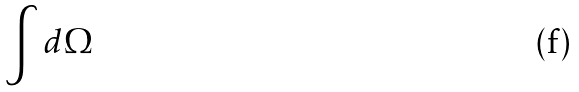Convert formula to latex. <formula><loc_0><loc_0><loc_500><loc_500>\int d \Omega</formula> 